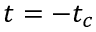<formula> <loc_0><loc_0><loc_500><loc_500>t = - t _ { c }</formula> 